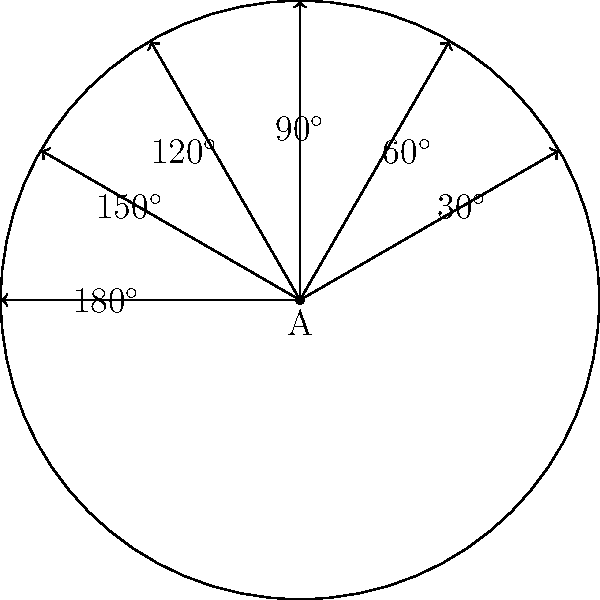In a circular office space at KPMG India's Mumbai office, you need to optimize the arrangement of cubicles. The office has a radius of 10 meters, and you want to place 6 cubicles along the perimeter at equal angular intervals. If the first cubicle is placed at $30^\circ$ (as shown in the diagram), what are the polar coordinates $(r, \theta)$ of the fourth cubicle? To solve this problem, let's follow these steps:

1) First, we need to determine the angular interval between each cubicle:
   Total angle = $360^\circ = 2\pi$ radians
   Number of intervals = 6
   Angular interval = $360^\circ / 6 = 60^\circ = \pi/3$ radians

2) The first cubicle is at $30^\circ = \pi/6$ radians

3) To find the angle of the fourth cubicle, we add 3 intervals to the first cubicle's angle:
   $\theta = \pi/6 + 3(\pi/3) = \pi/6 + \pi = 7\pi/6$ radians

4) The radius remains constant at 10 meters for all cubicles.

5) Therefore, the polar coordinates of the fourth cubicle are:
   $(r, \theta) = (10, 7\pi/6)$

6) We can also express this in degrees:
   $7\pi/6$ radians = $210^\circ$

So, the polar coordinates can also be written as $(10, 210^\circ)$.
Answer: $(10, 7\pi/6)$ or $(10, 210^\circ)$ 